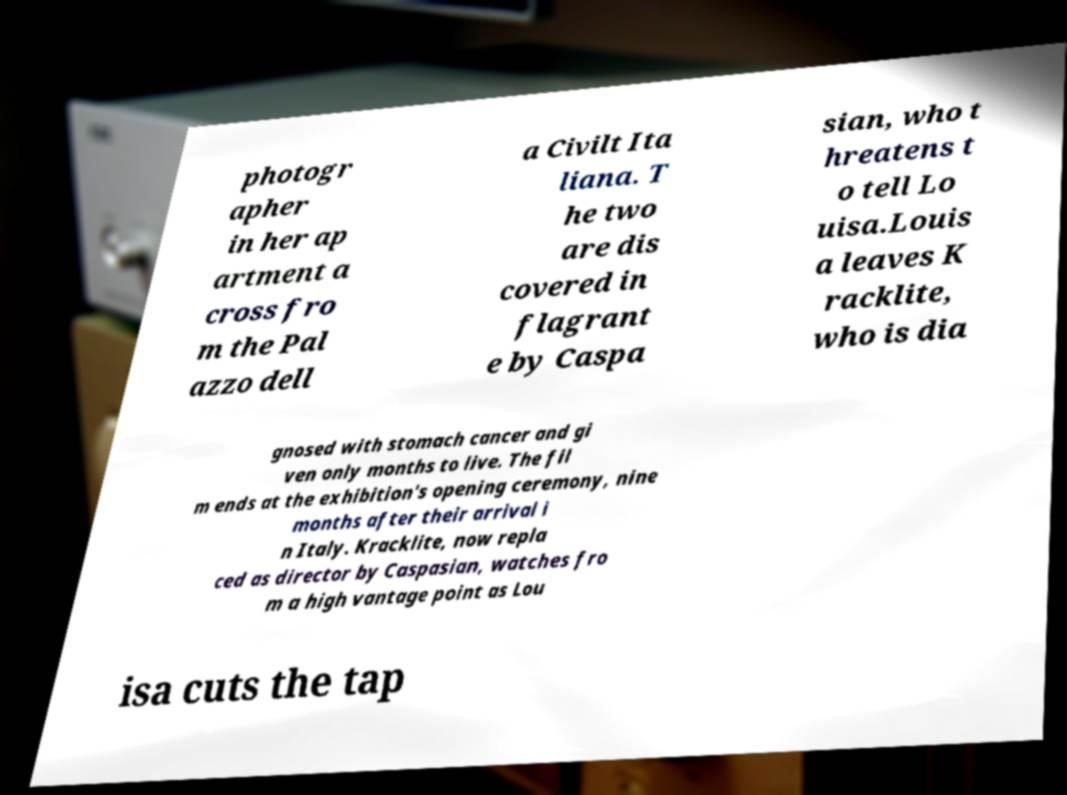For documentation purposes, I need the text within this image transcribed. Could you provide that? photogr apher in her ap artment a cross fro m the Pal azzo dell a Civilt Ita liana. T he two are dis covered in flagrant e by Caspa sian, who t hreatens t o tell Lo uisa.Louis a leaves K racklite, who is dia gnosed with stomach cancer and gi ven only months to live. The fil m ends at the exhibition's opening ceremony, nine months after their arrival i n Italy. Kracklite, now repla ced as director by Caspasian, watches fro m a high vantage point as Lou isa cuts the tap 